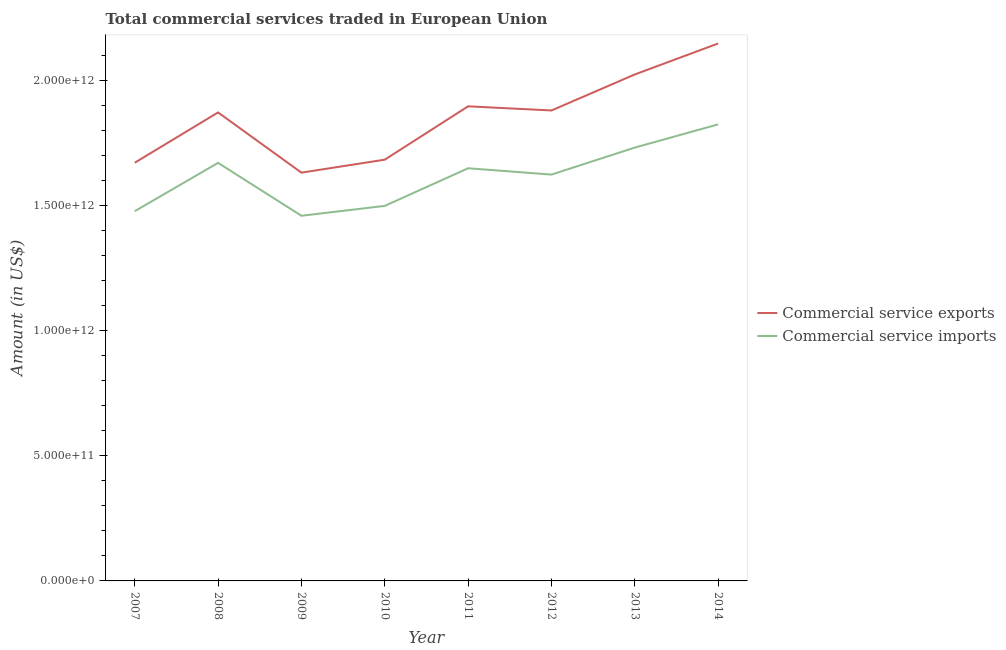What is the amount of commercial service exports in 2011?
Ensure brevity in your answer.  1.90e+12. Across all years, what is the maximum amount of commercial service imports?
Give a very brief answer. 1.82e+12. Across all years, what is the minimum amount of commercial service imports?
Provide a succinct answer. 1.46e+12. What is the total amount of commercial service exports in the graph?
Provide a short and direct response. 1.48e+13. What is the difference between the amount of commercial service imports in 2009 and that in 2010?
Your response must be concise. -3.96e+1. What is the difference between the amount of commercial service exports in 2013 and the amount of commercial service imports in 2014?
Ensure brevity in your answer.  1.99e+11. What is the average amount of commercial service imports per year?
Your answer should be very brief. 1.62e+12. In the year 2014, what is the difference between the amount of commercial service exports and amount of commercial service imports?
Offer a terse response. 3.23e+11. In how many years, is the amount of commercial service imports greater than 500000000000 US$?
Provide a short and direct response. 8. What is the ratio of the amount of commercial service imports in 2008 to that in 2012?
Keep it short and to the point. 1.03. What is the difference between the highest and the second highest amount of commercial service exports?
Keep it short and to the point. 1.24e+11. What is the difference between the highest and the lowest amount of commercial service imports?
Ensure brevity in your answer.  3.65e+11. Does the amount of commercial service imports monotonically increase over the years?
Offer a very short reply. No. What is the difference between two consecutive major ticks on the Y-axis?
Offer a terse response. 5.00e+11. Are the values on the major ticks of Y-axis written in scientific E-notation?
Make the answer very short. Yes. Does the graph contain grids?
Provide a succinct answer. No. How many legend labels are there?
Your answer should be very brief. 2. What is the title of the graph?
Give a very brief answer. Total commercial services traded in European Union. What is the label or title of the X-axis?
Make the answer very short. Year. What is the Amount (in US$) of Commercial service exports in 2007?
Your response must be concise. 1.67e+12. What is the Amount (in US$) in Commercial service imports in 2007?
Keep it short and to the point. 1.48e+12. What is the Amount (in US$) in Commercial service exports in 2008?
Offer a terse response. 1.87e+12. What is the Amount (in US$) of Commercial service imports in 2008?
Provide a short and direct response. 1.67e+12. What is the Amount (in US$) of Commercial service exports in 2009?
Your response must be concise. 1.63e+12. What is the Amount (in US$) of Commercial service imports in 2009?
Your response must be concise. 1.46e+12. What is the Amount (in US$) of Commercial service exports in 2010?
Ensure brevity in your answer.  1.68e+12. What is the Amount (in US$) of Commercial service imports in 2010?
Your response must be concise. 1.50e+12. What is the Amount (in US$) of Commercial service exports in 2011?
Offer a terse response. 1.90e+12. What is the Amount (in US$) of Commercial service imports in 2011?
Ensure brevity in your answer.  1.65e+12. What is the Amount (in US$) of Commercial service exports in 2012?
Ensure brevity in your answer.  1.88e+12. What is the Amount (in US$) of Commercial service imports in 2012?
Your answer should be compact. 1.62e+12. What is the Amount (in US$) in Commercial service exports in 2013?
Your response must be concise. 2.02e+12. What is the Amount (in US$) of Commercial service imports in 2013?
Ensure brevity in your answer.  1.73e+12. What is the Amount (in US$) in Commercial service exports in 2014?
Your answer should be very brief. 2.15e+12. What is the Amount (in US$) of Commercial service imports in 2014?
Offer a very short reply. 1.82e+12. Across all years, what is the maximum Amount (in US$) in Commercial service exports?
Provide a succinct answer. 2.15e+12. Across all years, what is the maximum Amount (in US$) in Commercial service imports?
Your answer should be compact. 1.82e+12. Across all years, what is the minimum Amount (in US$) in Commercial service exports?
Provide a succinct answer. 1.63e+12. Across all years, what is the minimum Amount (in US$) of Commercial service imports?
Provide a short and direct response. 1.46e+12. What is the total Amount (in US$) in Commercial service exports in the graph?
Provide a short and direct response. 1.48e+13. What is the total Amount (in US$) in Commercial service imports in the graph?
Keep it short and to the point. 1.29e+13. What is the difference between the Amount (in US$) in Commercial service exports in 2007 and that in 2008?
Your answer should be very brief. -2.01e+11. What is the difference between the Amount (in US$) of Commercial service imports in 2007 and that in 2008?
Your answer should be compact. -1.93e+11. What is the difference between the Amount (in US$) of Commercial service exports in 2007 and that in 2009?
Keep it short and to the point. 3.96e+1. What is the difference between the Amount (in US$) in Commercial service imports in 2007 and that in 2009?
Offer a very short reply. 1.83e+1. What is the difference between the Amount (in US$) in Commercial service exports in 2007 and that in 2010?
Offer a very short reply. -1.23e+1. What is the difference between the Amount (in US$) in Commercial service imports in 2007 and that in 2010?
Your answer should be compact. -2.13e+1. What is the difference between the Amount (in US$) of Commercial service exports in 2007 and that in 2011?
Your answer should be compact. -2.25e+11. What is the difference between the Amount (in US$) in Commercial service imports in 2007 and that in 2011?
Give a very brief answer. -1.71e+11. What is the difference between the Amount (in US$) of Commercial service exports in 2007 and that in 2012?
Keep it short and to the point. -2.09e+11. What is the difference between the Amount (in US$) in Commercial service imports in 2007 and that in 2012?
Ensure brevity in your answer.  -1.46e+11. What is the difference between the Amount (in US$) of Commercial service exports in 2007 and that in 2013?
Make the answer very short. -3.53e+11. What is the difference between the Amount (in US$) in Commercial service imports in 2007 and that in 2013?
Offer a very short reply. -2.54e+11. What is the difference between the Amount (in US$) in Commercial service exports in 2007 and that in 2014?
Make the answer very short. -4.76e+11. What is the difference between the Amount (in US$) in Commercial service imports in 2007 and that in 2014?
Your answer should be compact. -3.47e+11. What is the difference between the Amount (in US$) in Commercial service exports in 2008 and that in 2009?
Provide a succinct answer. 2.41e+11. What is the difference between the Amount (in US$) of Commercial service imports in 2008 and that in 2009?
Offer a very short reply. 2.11e+11. What is the difference between the Amount (in US$) in Commercial service exports in 2008 and that in 2010?
Your answer should be compact. 1.89e+11. What is the difference between the Amount (in US$) in Commercial service imports in 2008 and that in 2010?
Keep it short and to the point. 1.72e+11. What is the difference between the Amount (in US$) in Commercial service exports in 2008 and that in 2011?
Provide a short and direct response. -2.44e+1. What is the difference between the Amount (in US$) in Commercial service imports in 2008 and that in 2011?
Provide a succinct answer. 2.16e+1. What is the difference between the Amount (in US$) in Commercial service exports in 2008 and that in 2012?
Your response must be concise. -7.82e+09. What is the difference between the Amount (in US$) in Commercial service imports in 2008 and that in 2012?
Provide a succinct answer. 4.68e+1. What is the difference between the Amount (in US$) in Commercial service exports in 2008 and that in 2013?
Provide a succinct answer. -1.52e+11. What is the difference between the Amount (in US$) of Commercial service imports in 2008 and that in 2013?
Your answer should be very brief. -6.11e+1. What is the difference between the Amount (in US$) in Commercial service exports in 2008 and that in 2014?
Keep it short and to the point. -2.75e+11. What is the difference between the Amount (in US$) of Commercial service imports in 2008 and that in 2014?
Provide a short and direct response. -1.54e+11. What is the difference between the Amount (in US$) in Commercial service exports in 2009 and that in 2010?
Keep it short and to the point. -5.19e+1. What is the difference between the Amount (in US$) in Commercial service imports in 2009 and that in 2010?
Give a very brief answer. -3.96e+1. What is the difference between the Amount (in US$) of Commercial service exports in 2009 and that in 2011?
Make the answer very short. -2.65e+11. What is the difference between the Amount (in US$) in Commercial service imports in 2009 and that in 2011?
Offer a terse response. -1.90e+11. What is the difference between the Amount (in US$) of Commercial service exports in 2009 and that in 2012?
Ensure brevity in your answer.  -2.48e+11. What is the difference between the Amount (in US$) in Commercial service imports in 2009 and that in 2012?
Keep it short and to the point. -1.65e+11. What is the difference between the Amount (in US$) of Commercial service exports in 2009 and that in 2013?
Provide a succinct answer. -3.92e+11. What is the difference between the Amount (in US$) in Commercial service imports in 2009 and that in 2013?
Your response must be concise. -2.72e+11. What is the difference between the Amount (in US$) in Commercial service exports in 2009 and that in 2014?
Offer a very short reply. -5.16e+11. What is the difference between the Amount (in US$) in Commercial service imports in 2009 and that in 2014?
Your answer should be very brief. -3.65e+11. What is the difference between the Amount (in US$) of Commercial service exports in 2010 and that in 2011?
Offer a very short reply. -2.13e+11. What is the difference between the Amount (in US$) of Commercial service imports in 2010 and that in 2011?
Your answer should be very brief. -1.50e+11. What is the difference between the Amount (in US$) in Commercial service exports in 2010 and that in 2012?
Provide a short and direct response. -1.96e+11. What is the difference between the Amount (in US$) of Commercial service imports in 2010 and that in 2012?
Ensure brevity in your answer.  -1.25e+11. What is the difference between the Amount (in US$) in Commercial service exports in 2010 and that in 2013?
Offer a very short reply. -3.40e+11. What is the difference between the Amount (in US$) of Commercial service imports in 2010 and that in 2013?
Make the answer very short. -2.33e+11. What is the difference between the Amount (in US$) of Commercial service exports in 2010 and that in 2014?
Offer a terse response. -4.64e+11. What is the difference between the Amount (in US$) in Commercial service imports in 2010 and that in 2014?
Give a very brief answer. -3.26e+11. What is the difference between the Amount (in US$) of Commercial service exports in 2011 and that in 2012?
Provide a succinct answer. 1.66e+1. What is the difference between the Amount (in US$) in Commercial service imports in 2011 and that in 2012?
Offer a very short reply. 2.52e+1. What is the difference between the Amount (in US$) in Commercial service exports in 2011 and that in 2013?
Make the answer very short. -1.27e+11. What is the difference between the Amount (in US$) in Commercial service imports in 2011 and that in 2013?
Your answer should be compact. -8.27e+1. What is the difference between the Amount (in US$) of Commercial service exports in 2011 and that in 2014?
Ensure brevity in your answer.  -2.51e+11. What is the difference between the Amount (in US$) of Commercial service imports in 2011 and that in 2014?
Ensure brevity in your answer.  -1.75e+11. What is the difference between the Amount (in US$) in Commercial service exports in 2012 and that in 2013?
Provide a succinct answer. -1.44e+11. What is the difference between the Amount (in US$) in Commercial service imports in 2012 and that in 2013?
Offer a very short reply. -1.08e+11. What is the difference between the Amount (in US$) of Commercial service exports in 2012 and that in 2014?
Give a very brief answer. -2.68e+11. What is the difference between the Amount (in US$) in Commercial service imports in 2012 and that in 2014?
Offer a terse response. -2.01e+11. What is the difference between the Amount (in US$) in Commercial service exports in 2013 and that in 2014?
Your answer should be compact. -1.24e+11. What is the difference between the Amount (in US$) of Commercial service imports in 2013 and that in 2014?
Your answer should be compact. -9.27e+1. What is the difference between the Amount (in US$) of Commercial service exports in 2007 and the Amount (in US$) of Commercial service imports in 2008?
Offer a very short reply. 5.13e+08. What is the difference between the Amount (in US$) of Commercial service exports in 2007 and the Amount (in US$) of Commercial service imports in 2009?
Offer a very short reply. 2.12e+11. What is the difference between the Amount (in US$) of Commercial service exports in 2007 and the Amount (in US$) of Commercial service imports in 2010?
Your answer should be compact. 1.72e+11. What is the difference between the Amount (in US$) of Commercial service exports in 2007 and the Amount (in US$) of Commercial service imports in 2011?
Offer a very short reply. 2.21e+1. What is the difference between the Amount (in US$) of Commercial service exports in 2007 and the Amount (in US$) of Commercial service imports in 2012?
Make the answer very short. 4.73e+1. What is the difference between the Amount (in US$) of Commercial service exports in 2007 and the Amount (in US$) of Commercial service imports in 2013?
Provide a succinct answer. -6.06e+1. What is the difference between the Amount (in US$) of Commercial service exports in 2007 and the Amount (in US$) of Commercial service imports in 2014?
Keep it short and to the point. -1.53e+11. What is the difference between the Amount (in US$) of Commercial service exports in 2008 and the Amount (in US$) of Commercial service imports in 2009?
Your answer should be very brief. 4.13e+11. What is the difference between the Amount (in US$) of Commercial service exports in 2008 and the Amount (in US$) of Commercial service imports in 2010?
Provide a short and direct response. 3.73e+11. What is the difference between the Amount (in US$) in Commercial service exports in 2008 and the Amount (in US$) in Commercial service imports in 2011?
Offer a very short reply. 2.23e+11. What is the difference between the Amount (in US$) in Commercial service exports in 2008 and the Amount (in US$) in Commercial service imports in 2012?
Your answer should be very brief. 2.48e+11. What is the difference between the Amount (in US$) of Commercial service exports in 2008 and the Amount (in US$) of Commercial service imports in 2013?
Give a very brief answer. 1.40e+11. What is the difference between the Amount (in US$) in Commercial service exports in 2008 and the Amount (in US$) in Commercial service imports in 2014?
Make the answer very short. 4.77e+1. What is the difference between the Amount (in US$) in Commercial service exports in 2009 and the Amount (in US$) in Commercial service imports in 2010?
Make the answer very short. 1.33e+11. What is the difference between the Amount (in US$) of Commercial service exports in 2009 and the Amount (in US$) of Commercial service imports in 2011?
Offer a very short reply. -1.75e+1. What is the difference between the Amount (in US$) of Commercial service exports in 2009 and the Amount (in US$) of Commercial service imports in 2012?
Offer a very short reply. 7.71e+09. What is the difference between the Amount (in US$) of Commercial service exports in 2009 and the Amount (in US$) of Commercial service imports in 2013?
Your answer should be very brief. -1.00e+11. What is the difference between the Amount (in US$) in Commercial service exports in 2009 and the Amount (in US$) in Commercial service imports in 2014?
Provide a succinct answer. -1.93e+11. What is the difference between the Amount (in US$) of Commercial service exports in 2010 and the Amount (in US$) of Commercial service imports in 2011?
Offer a terse response. 3.44e+1. What is the difference between the Amount (in US$) of Commercial service exports in 2010 and the Amount (in US$) of Commercial service imports in 2012?
Your response must be concise. 5.96e+1. What is the difference between the Amount (in US$) of Commercial service exports in 2010 and the Amount (in US$) of Commercial service imports in 2013?
Keep it short and to the point. -4.83e+1. What is the difference between the Amount (in US$) in Commercial service exports in 2010 and the Amount (in US$) in Commercial service imports in 2014?
Ensure brevity in your answer.  -1.41e+11. What is the difference between the Amount (in US$) of Commercial service exports in 2011 and the Amount (in US$) of Commercial service imports in 2012?
Provide a succinct answer. 2.73e+11. What is the difference between the Amount (in US$) in Commercial service exports in 2011 and the Amount (in US$) in Commercial service imports in 2013?
Provide a short and direct response. 1.65e+11. What is the difference between the Amount (in US$) in Commercial service exports in 2011 and the Amount (in US$) in Commercial service imports in 2014?
Provide a short and direct response. 7.21e+1. What is the difference between the Amount (in US$) of Commercial service exports in 2012 and the Amount (in US$) of Commercial service imports in 2013?
Your response must be concise. 1.48e+11. What is the difference between the Amount (in US$) of Commercial service exports in 2012 and the Amount (in US$) of Commercial service imports in 2014?
Make the answer very short. 5.55e+1. What is the difference between the Amount (in US$) of Commercial service exports in 2013 and the Amount (in US$) of Commercial service imports in 2014?
Your response must be concise. 1.99e+11. What is the average Amount (in US$) in Commercial service exports per year?
Provide a succinct answer. 1.85e+12. What is the average Amount (in US$) of Commercial service imports per year?
Ensure brevity in your answer.  1.62e+12. In the year 2007, what is the difference between the Amount (in US$) of Commercial service exports and Amount (in US$) of Commercial service imports?
Provide a short and direct response. 1.94e+11. In the year 2008, what is the difference between the Amount (in US$) of Commercial service exports and Amount (in US$) of Commercial service imports?
Provide a succinct answer. 2.01e+11. In the year 2009, what is the difference between the Amount (in US$) in Commercial service exports and Amount (in US$) in Commercial service imports?
Give a very brief answer. 1.72e+11. In the year 2010, what is the difference between the Amount (in US$) of Commercial service exports and Amount (in US$) of Commercial service imports?
Offer a very short reply. 1.85e+11. In the year 2011, what is the difference between the Amount (in US$) of Commercial service exports and Amount (in US$) of Commercial service imports?
Your response must be concise. 2.47e+11. In the year 2012, what is the difference between the Amount (in US$) in Commercial service exports and Amount (in US$) in Commercial service imports?
Offer a very short reply. 2.56e+11. In the year 2013, what is the difference between the Amount (in US$) in Commercial service exports and Amount (in US$) in Commercial service imports?
Provide a short and direct response. 2.92e+11. In the year 2014, what is the difference between the Amount (in US$) of Commercial service exports and Amount (in US$) of Commercial service imports?
Your response must be concise. 3.23e+11. What is the ratio of the Amount (in US$) of Commercial service exports in 2007 to that in 2008?
Make the answer very short. 0.89. What is the ratio of the Amount (in US$) in Commercial service imports in 2007 to that in 2008?
Offer a very short reply. 0.88. What is the ratio of the Amount (in US$) of Commercial service exports in 2007 to that in 2009?
Your response must be concise. 1.02. What is the ratio of the Amount (in US$) in Commercial service imports in 2007 to that in 2009?
Your answer should be very brief. 1.01. What is the ratio of the Amount (in US$) in Commercial service exports in 2007 to that in 2010?
Provide a succinct answer. 0.99. What is the ratio of the Amount (in US$) in Commercial service imports in 2007 to that in 2010?
Your answer should be compact. 0.99. What is the ratio of the Amount (in US$) of Commercial service exports in 2007 to that in 2011?
Give a very brief answer. 0.88. What is the ratio of the Amount (in US$) in Commercial service imports in 2007 to that in 2011?
Your answer should be compact. 0.9. What is the ratio of the Amount (in US$) of Commercial service imports in 2007 to that in 2012?
Your answer should be very brief. 0.91. What is the ratio of the Amount (in US$) of Commercial service exports in 2007 to that in 2013?
Ensure brevity in your answer.  0.83. What is the ratio of the Amount (in US$) of Commercial service imports in 2007 to that in 2013?
Provide a succinct answer. 0.85. What is the ratio of the Amount (in US$) of Commercial service exports in 2007 to that in 2014?
Offer a very short reply. 0.78. What is the ratio of the Amount (in US$) in Commercial service imports in 2007 to that in 2014?
Provide a succinct answer. 0.81. What is the ratio of the Amount (in US$) in Commercial service exports in 2008 to that in 2009?
Offer a very short reply. 1.15. What is the ratio of the Amount (in US$) of Commercial service imports in 2008 to that in 2009?
Your response must be concise. 1.14. What is the ratio of the Amount (in US$) of Commercial service exports in 2008 to that in 2010?
Keep it short and to the point. 1.11. What is the ratio of the Amount (in US$) of Commercial service imports in 2008 to that in 2010?
Offer a very short reply. 1.11. What is the ratio of the Amount (in US$) of Commercial service exports in 2008 to that in 2011?
Give a very brief answer. 0.99. What is the ratio of the Amount (in US$) of Commercial service imports in 2008 to that in 2011?
Provide a succinct answer. 1.01. What is the ratio of the Amount (in US$) in Commercial service imports in 2008 to that in 2012?
Give a very brief answer. 1.03. What is the ratio of the Amount (in US$) of Commercial service exports in 2008 to that in 2013?
Ensure brevity in your answer.  0.93. What is the ratio of the Amount (in US$) in Commercial service imports in 2008 to that in 2013?
Ensure brevity in your answer.  0.96. What is the ratio of the Amount (in US$) of Commercial service exports in 2008 to that in 2014?
Keep it short and to the point. 0.87. What is the ratio of the Amount (in US$) in Commercial service imports in 2008 to that in 2014?
Ensure brevity in your answer.  0.92. What is the ratio of the Amount (in US$) of Commercial service exports in 2009 to that in 2010?
Offer a terse response. 0.97. What is the ratio of the Amount (in US$) in Commercial service imports in 2009 to that in 2010?
Provide a succinct answer. 0.97. What is the ratio of the Amount (in US$) in Commercial service exports in 2009 to that in 2011?
Make the answer very short. 0.86. What is the ratio of the Amount (in US$) in Commercial service imports in 2009 to that in 2011?
Provide a succinct answer. 0.88. What is the ratio of the Amount (in US$) in Commercial service exports in 2009 to that in 2012?
Offer a very short reply. 0.87. What is the ratio of the Amount (in US$) of Commercial service imports in 2009 to that in 2012?
Make the answer very short. 0.9. What is the ratio of the Amount (in US$) in Commercial service exports in 2009 to that in 2013?
Provide a succinct answer. 0.81. What is the ratio of the Amount (in US$) in Commercial service imports in 2009 to that in 2013?
Keep it short and to the point. 0.84. What is the ratio of the Amount (in US$) of Commercial service exports in 2009 to that in 2014?
Offer a terse response. 0.76. What is the ratio of the Amount (in US$) of Commercial service imports in 2009 to that in 2014?
Offer a very short reply. 0.8. What is the ratio of the Amount (in US$) of Commercial service exports in 2010 to that in 2011?
Ensure brevity in your answer.  0.89. What is the ratio of the Amount (in US$) in Commercial service imports in 2010 to that in 2011?
Your answer should be very brief. 0.91. What is the ratio of the Amount (in US$) of Commercial service exports in 2010 to that in 2012?
Provide a short and direct response. 0.9. What is the ratio of the Amount (in US$) of Commercial service imports in 2010 to that in 2012?
Your response must be concise. 0.92. What is the ratio of the Amount (in US$) of Commercial service exports in 2010 to that in 2013?
Give a very brief answer. 0.83. What is the ratio of the Amount (in US$) in Commercial service imports in 2010 to that in 2013?
Your answer should be very brief. 0.87. What is the ratio of the Amount (in US$) of Commercial service exports in 2010 to that in 2014?
Give a very brief answer. 0.78. What is the ratio of the Amount (in US$) in Commercial service imports in 2010 to that in 2014?
Provide a short and direct response. 0.82. What is the ratio of the Amount (in US$) of Commercial service exports in 2011 to that in 2012?
Your answer should be compact. 1.01. What is the ratio of the Amount (in US$) of Commercial service imports in 2011 to that in 2012?
Offer a very short reply. 1.02. What is the ratio of the Amount (in US$) in Commercial service exports in 2011 to that in 2013?
Make the answer very short. 0.94. What is the ratio of the Amount (in US$) in Commercial service imports in 2011 to that in 2013?
Keep it short and to the point. 0.95. What is the ratio of the Amount (in US$) of Commercial service exports in 2011 to that in 2014?
Provide a short and direct response. 0.88. What is the ratio of the Amount (in US$) in Commercial service imports in 2011 to that in 2014?
Offer a very short reply. 0.9. What is the ratio of the Amount (in US$) of Commercial service exports in 2012 to that in 2013?
Keep it short and to the point. 0.93. What is the ratio of the Amount (in US$) of Commercial service imports in 2012 to that in 2013?
Ensure brevity in your answer.  0.94. What is the ratio of the Amount (in US$) in Commercial service exports in 2012 to that in 2014?
Your response must be concise. 0.88. What is the ratio of the Amount (in US$) in Commercial service imports in 2012 to that in 2014?
Offer a terse response. 0.89. What is the ratio of the Amount (in US$) in Commercial service exports in 2013 to that in 2014?
Provide a succinct answer. 0.94. What is the ratio of the Amount (in US$) of Commercial service imports in 2013 to that in 2014?
Provide a succinct answer. 0.95. What is the difference between the highest and the second highest Amount (in US$) in Commercial service exports?
Keep it short and to the point. 1.24e+11. What is the difference between the highest and the second highest Amount (in US$) in Commercial service imports?
Make the answer very short. 9.27e+1. What is the difference between the highest and the lowest Amount (in US$) in Commercial service exports?
Ensure brevity in your answer.  5.16e+11. What is the difference between the highest and the lowest Amount (in US$) of Commercial service imports?
Offer a very short reply. 3.65e+11. 